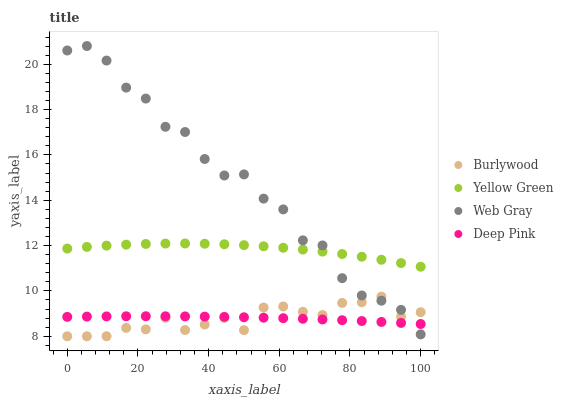Does Burlywood have the minimum area under the curve?
Answer yes or no. Yes. Does Web Gray have the maximum area under the curve?
Answer yes or no. Yes. Does Yellow Green have the minimum area under the curve?
Answer yes or no. No. Does Yellow Green have the maximum area under the curve?
Answer yes or no. No. Is Deep Pink the smoothest?
Answer yes or no. Yes. Is Web Gray the roughest?
Answer yes or no. Yes. Is Yellow Green the smoothest?
Answer yes or no. No. Is Yellow Green the roughest?
Answer yes or no. No. Does Burlywood have the lowest value?
Answer yes or no. Yes. Does Web Gray have the lowest value?
Answer yes or no. No. Does Web Gray have the highest value?
Answer yes or no. Yes. Does Yellow Green have the highest value?
Answer yes or no. No. Is Burlywood less than Yellow Green?
Answer yes or no. Yes. Is Yellow Green greater than Deep Pink?
Answer yes or no. Yes. Does Web Gray intersect Deep Pink?
Answer yes or no. Yes. Is Web Gray less than Deep Pink?
Answer yes or no. No. Is Web Gray greater than Deep Pink?
Answer yes or no. No. Does Burlywood intersect Yellow Green?
Answer yes or no. No. 